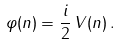Convert formula to latex. <formula><loc_0><loc_0><loc_500><loc_500>\varphi ( n ) = \frac { i } { 2 } \, V ( n ) \, .</formula> 